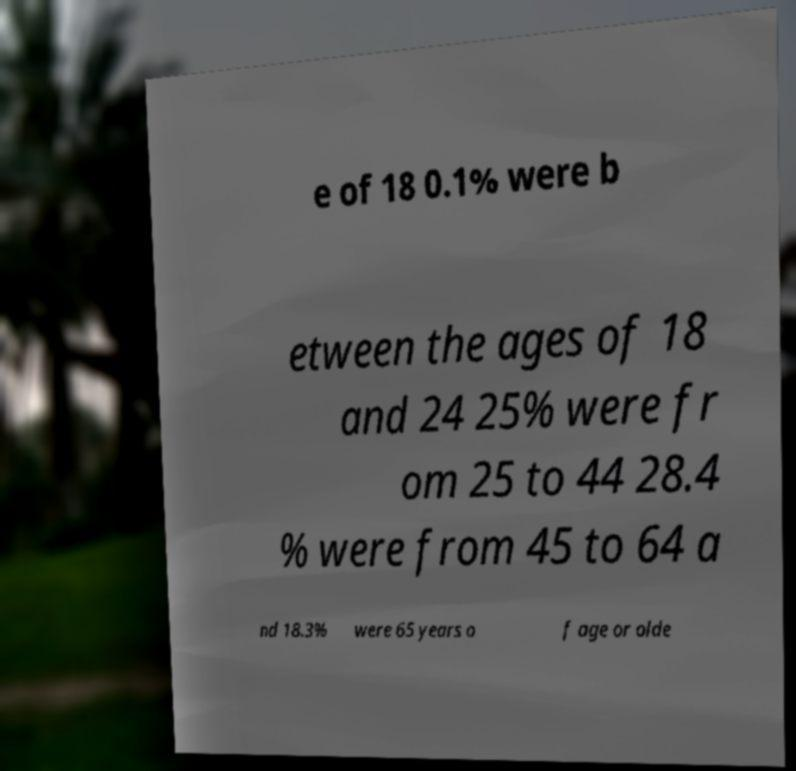For documentation purposes, I need the text within this image transcribed. Could you provide that? e of 18 0.1% were b etween the ages of 18 and 24 25% were fr om 25 to 44 28.4 % were from 45 to 64 a nd 18.3% were 65 years o f age or olde 